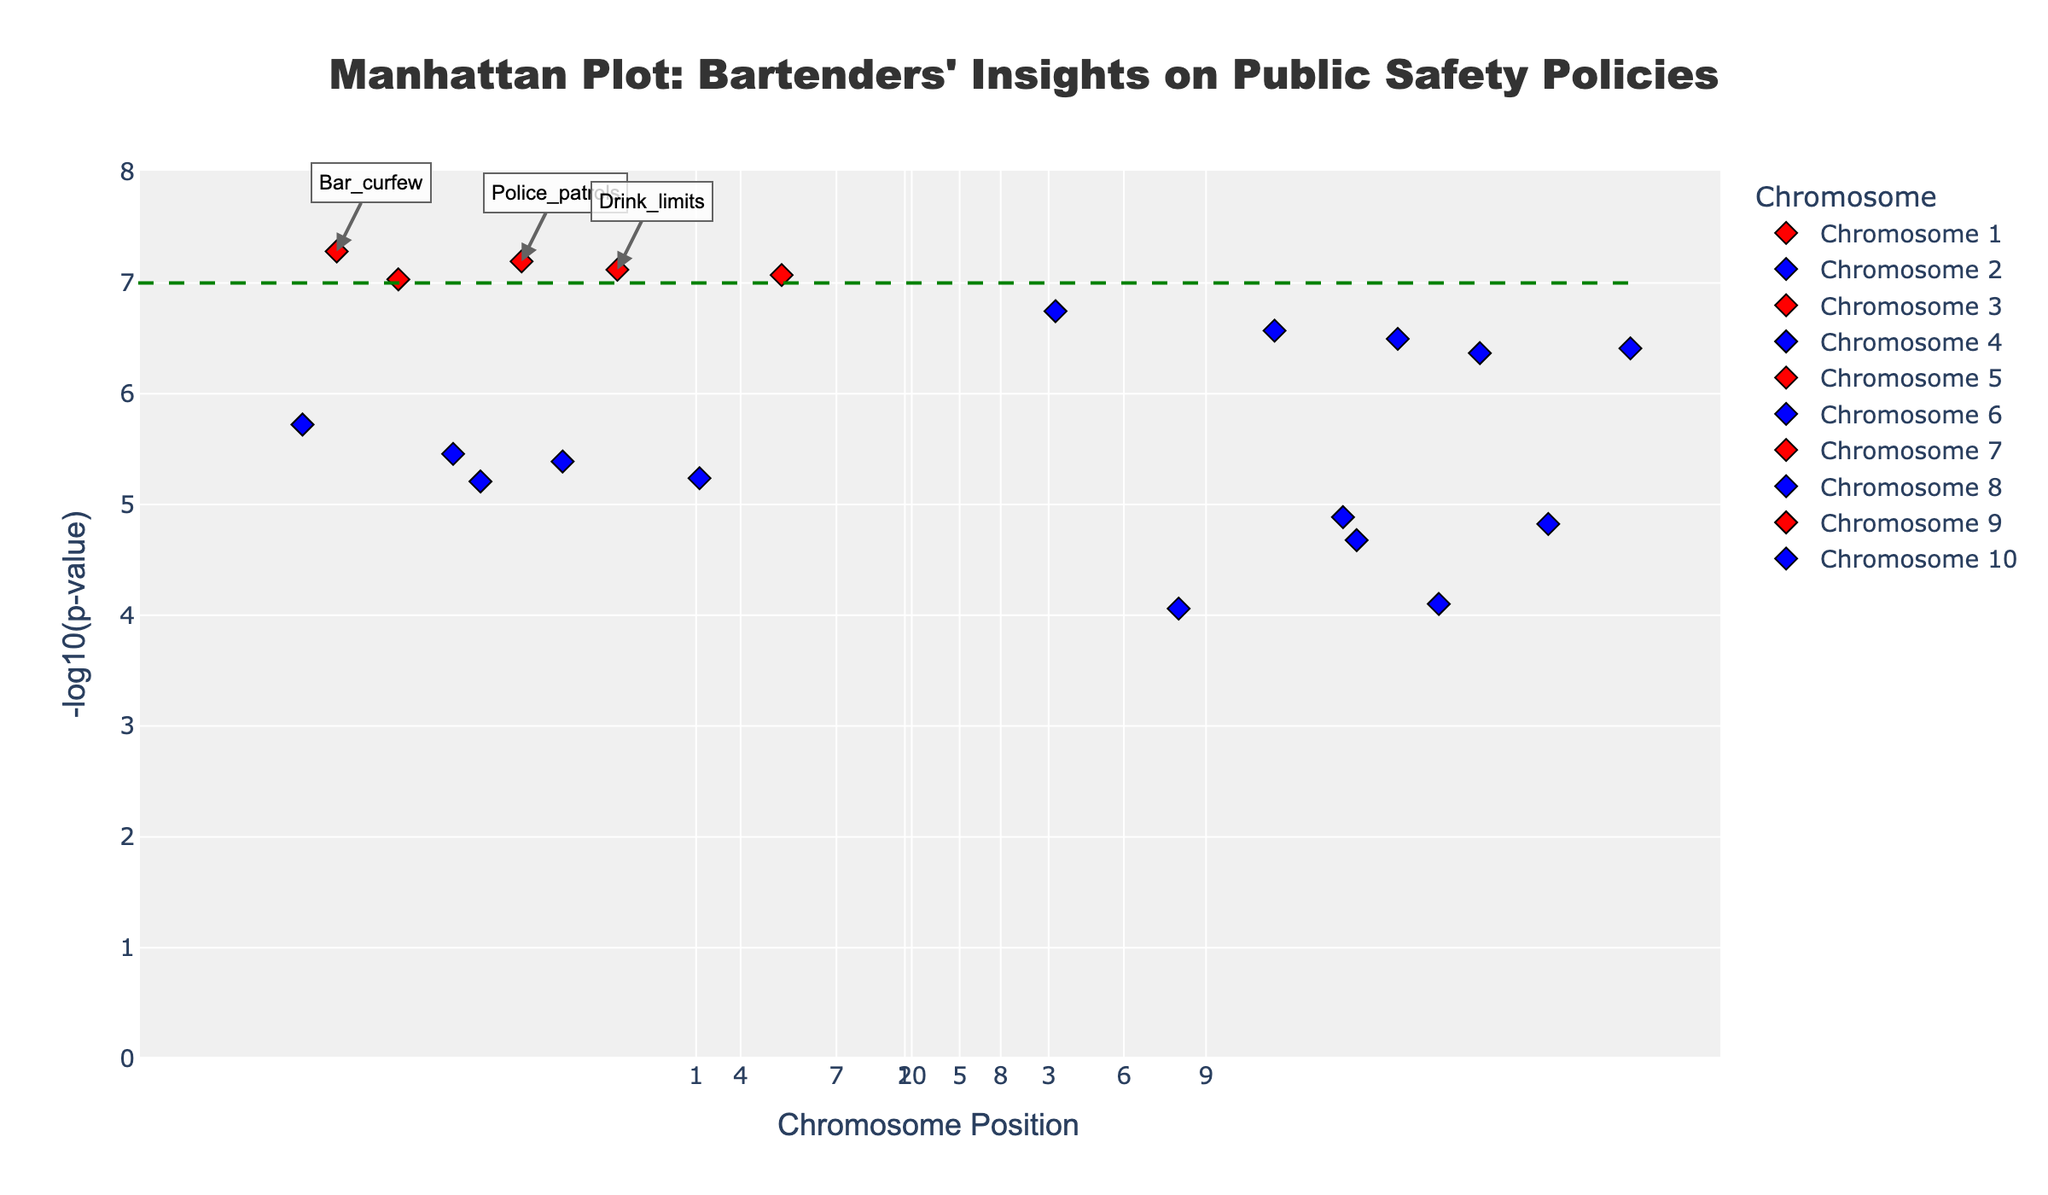What is the title of the plot? The title is often located at the top of the plot and describes the main focus or purpose of the figure.
Answer: Manhattan Plot: Bartenders' Insights on Public Safety Policies How many chromosomes are represented in the plot? The x-axis typically depicts different chromosomes, identifiable by their unique ticks or groups. Counting these ticks provides the number of chromosomes.
Answer: 10 Which policy proposals are considered statistically significant based on the threshold line? Policies corresponding to red markers and above the horizontal dashed green line are statistically significant. These markers are labeled for easy identification.
Answer: Bar_curfew, Drink_limits, Police_patrols, Conflict_resolution, Bartender_certification Which chromosome contains the proposal with the lowest p-value? The proposal with the lowest p-value has the highest -log10(p) value and is marked in red. Identify its corresponding chromosome on the plot.
Answer: Chromosome 7 What is the -log10(p-value) threshold for significance? The threshold is represented by a horizontal dashed green line. The y-value of this line indicates the -log10(p-value) threshold.
Answer: 7 What is the position of "Bouncer_training" on its chromosome? By hovering over or locating the marker corresponding to "Bouncer_training" on the plot, its precise position on the chromosome can be identified.
Answer: 67,000,000 Which policy proposal on Chromosome 3 has a higher -log10(p-value)? There are two proposals on Chromosome 3: "Drink_limits" and "Security_cameras". Compare their heights on the y-axis to determine which one has the higher value.
Answer: Drink_limits How many policy proposals have a -log10(p-value) higher than 6? Identify and count all markers on the plot located above the y-value of 6. These markers represent the proposals with -log10(p-value) higher than 6.
Answer: 10 Is "Public_transport" considered statistically significant at the 1e-7 threshold? Check whether the marker for "Public_transport" is above the green dashed threshold line. If it is below, it is not statistically significant at the 1e-7 threshold.
Answer: No What is the highest -log10(p-value) observed in the plot? The tallest marker on the plot corresponds to the highest -log10(p-value). Identify and read this value from the y-axis.
Answer: Around 7.03 